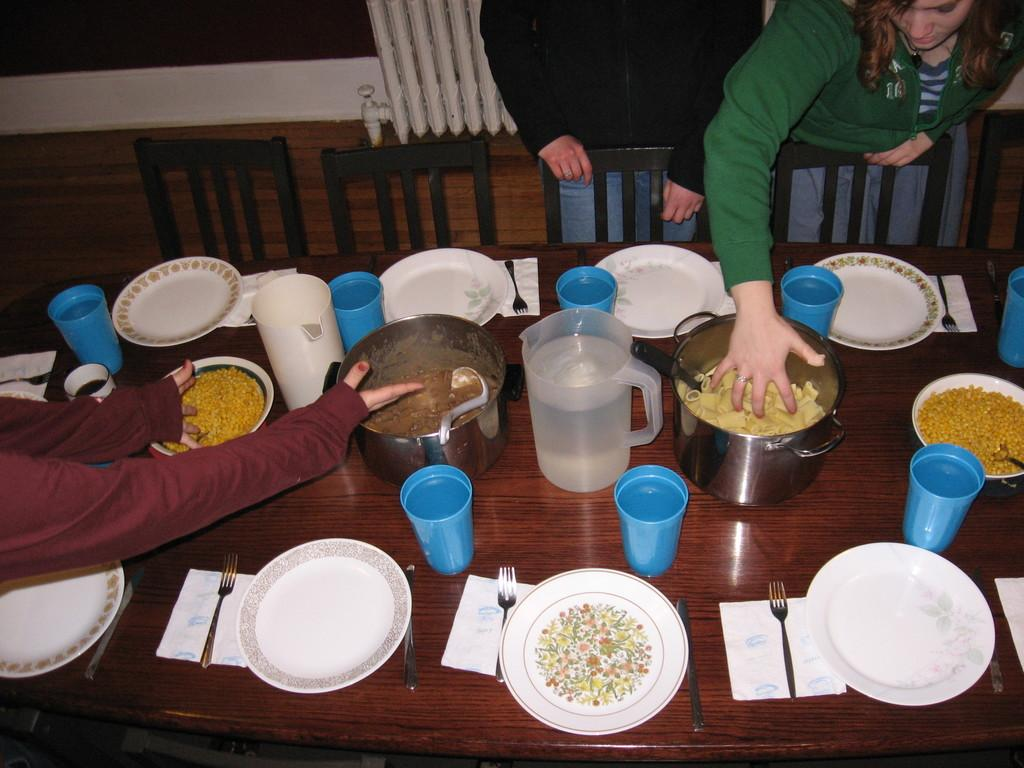What type of tableware can be seen in the image? There are plates, napkins, and forks in the image. What is the purpose of the water jug in the image? The water jug is likely for serving water or other beverages. What type of glasses are present in the image? There are glasses in the image, which are typically used for drinking. What can be inferred about the food items in the image? The presence of plates, forks, and glasses suggests that the food items are meant to be eaten. How many people are present in the image? There are 3 people standing in the image. What type of seating is available in the image? There are chairs in the image. What type of desk can be seen in the image? There is no desk present in the image. How many walls are visible in the image? The image does not show any walls; it only shows the people, tableware, and food items. 